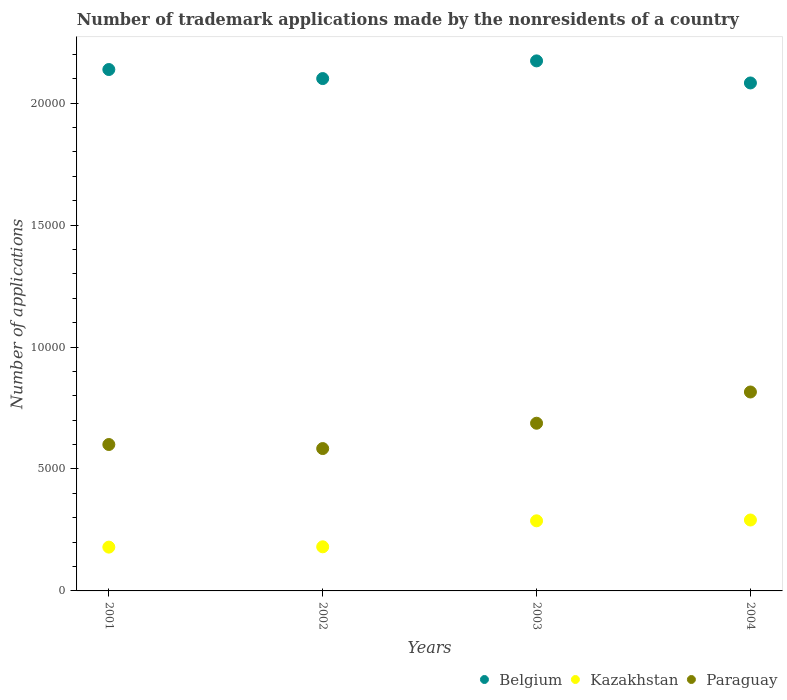How many different coloured dotlines are there?
Your response must be concise. 3. What is the number of trademark applications made by the nonresidents in Kazakhstan in 2002?
Your answer should be compact. 1809. Across all years, what is the maximum number of trademark applications made by the nonresidents in Kazakhstan?
Provide a succinct answer. 2908. Across all years, what is the minimum number of trademark applications made by the nonresidents in Belgium?
Provide a succinct answer. 2.08e+04. In which year was the number of trademark applications made by the nonresidents in Paraguay maximum?
Offer a very short reply. 2004. What is the total number of trademark applications made by the nonresidents in Belgium in the graph?
Ensure brevity in your answer.  8.50e+04. What is the difference between the number of trademark applications made by the nonresidents in Belgium in 2002 and that in 2004?
Keep it short and to the point. 180. What is the difference between the number of trademark applications made by the nonresidents in Belgium in 2003 and the number of trademark applications made by the nonresidents in Kazakhstan in 2001?
Your answer should be compact. 1.99e+04. What is the average number of trademark applications made by the nonresidents in Belgium per year?
Offer a terse response. 2.12e+04. In the year 2004, what is the difference between the number of trademark applications made by the nonresidents in Paraguay and number of trademark applications made by the nonresidents in Kazakhstan?
Your response must be concise. 5250. In how many years, is the number of trademark applications made by the nonresidents in Paraguay greater than 17000?
Make the answer very short. 0. What is the ratio of the number of trademark applications made by the nonresidents in Kazakhstan in 2001 to that in 2004?
Your answer should be very brief. 0.62. Is the number of trademark applications made by the nonresidents in Belgium in 2003 less than that in 2004?
Provide a short and direct response. No. What is the difference between the highest and the second highest number of trademark applications made by the nonresidents in Belgium?
Offer a very short reply. 354. What is the difference between the highest and the lowest number of trademark applications made by the nonresidents in Belgium?
Offer a very short reply. 905. In how many years, is the number of trademark applications made by the nonresidents in Kazakhstan greater than the average number of trademark applications made by the nonresidents in Kazakhstan taken over all years?
Provide a short and direct response. 2. How many dotlines are there?
Your answer should be compact. 3. What is the title of the graph?
Offer a very short reply. Number of trademark applications made by the nonresidents of a country. Does "Lao PDR" appear as one of the legend labels in the graph?
Your answer should be very brief. No. What is the label or title of the X-axis?
Keep it short and to the point. Years. What is the label or title of the Y-axis?
Ensure brevity in your answer.  Number of applications. What is the Number of applications in Belgium in 2001?
Provide a succinct answer. 2.14e+04. What is the Number of applications of Kazakhstan in 2001?
Make the answer very short. 1796. What is the Number of applications in Paraguay in 2001?
Your answer should be very brief. 6004. What is the Number of applications in Belgium in 2002?
Keep it short and to the point. 2.10e+04. What is the Number of applications in Kazakhstan in 2002?
Your answer should be very brief. 1809. What is the Number of applications of Paraguay in 2002?
Your response must be concise. 5838. What is the Number of applications of Belgium in 2003?
Ensure brevity in your answer.  2.17e+04. What is the Number of applications of Kazakhstan in 2003?
Ensure brevity in your answer.  2875. What is the Number of applications in Paraguay in 2003?
Your response must be concise. 6877. What is the Number of applications of Belgium in 2004?
Provide a succinct answer. 2.08e+04. What is the Number of applications in Kazakhstan in 2004?
Your answer should be very brief. 2908. What is the Number of applications in Paraguay in 2004?
Keep it short and to the point. 8158. Across all years, what is the maximum Number of applications in Belgium?
Ensure brevity in your answer.  2.17e+04. Across all years, what is the maximum Number of applications of Kazakhstan?
Your answer should be compact. 2908. Across all years, what is the maximum Number of applications in Paraguay?
Give a very brief answer. 8158. Across all years, what is the minimum Number of applications of Belgium?
Give a very brief answer. 2.08e+04. Across all years, what is the minimum Number of applications of Kazakhstan?
Provide a succinct answer. 1796. Across all years, what is the minimum Number of applications of Paraguay?
Your answer should be compact. 5838. What is the total Number of applications of Belgium in the graph?
Keep it short and to the point. 8.50e+04. What is the total Number of applications of Kazakhstan in the graph?
Your response must be concise. 9388. What is the total Number of applications in Paraguay in the graph?
Ensure brevity in your answer.  2.69e+04. What is the difference between the Number of applications in Belgium in 2001 and that in 2002?
Offer a terse response. 371. What is the difference between the Number of applications of Paraguay in 2001 and that in 2002?
Offer a terse response. 166. What is the difference between the Number of applications in Belgium in 2001 and that in 2003?
Your answer should be very brief. -354. What is the difference between the Number of applications in Kazakhstan in 2001 and that in 2003?
Keep it short and to the point. -1079. What is the difference between the Number of applications of Paraguay in 2001 and that in 2003?
Keep it short and to the point. -873. What is the difference between the Number of applications of Belgium in 2001 and that in 2004?
Your answer should be very brief. 551. What is the difference between the Number of applications of Kazakhstan in 2001 and that in 2004?
Give a very brief answer. -1112. What is the difference between the Number of applications of Paraguay in 2001 and that in 2004?
Provide a succinct answer. -2154. What is the difference between the Number of applications of Belgium in 2002 and that in 2003?
Ensure brevity in your answer.  -725. What is the difference between the Number of applications in Kazakhstan in 2002 and that in 2003?
Your answer should be compact. -1066. What is the difference between the Number of applications in Paraguay in 2002 and that in 2003?
Your response must be concise. -1039. What is the difference between the Number of applications in Belgium in 2002 and that in 2004?
Ensure brevity in your answer.  180. What is the difference between the Number of applications of Kazakhstan in 2002 and that in 2004?
Offer a very short reply. -1099. What is the difference between the Number of applications in Paraguay in 2002 and that in 2004?
Your response must be concise. -2320. What is the difference between the Number of applications in Belgium in 2003 and that in 2004?
Ensure brevity in your answer.  905. What is the difference between the Number of applications in Kazakhstan in 2003 and that in 2004?
Give a very brief answer. -33. What is the difference between the Number of applications of Paraguay in 2003 and that in 2004?
Make the answer very short. -1281. What is the difference between the Number of applications of Belgium in 2001 and the Number of applications of Kazakhstan in 2002?
Provide a succinct answer. 1.96e+04. What is the difference between the Number of applications in Belgium in 2001 and the Number of applications in Paraguay in 2002?
Give a very brief answer. 1.55e+04. What is the difference between the Number of applications of Kazakhstan in 2001 and the Number of applications of Paraguay in 2002?
Make the answer very short. -4042. What is the difference between the Number of applications of Belgium in 2001 and the Number of applications of Kazakhstan in 2003?
Your answer should be very brief. 1.85e+04. What is the difference between the Number of applications of Belgium in 2001 and the Number of applications of Paraguay in 2003?
Keep it short and to the point. 1.45e+04. What is the difference between the Number of applications of Kazakhstan in 2001 and the Number of applications of Paraguay in 2003?
Your answer should be very brief. -5081. What is the difference between the Number of applications of Belgium in 2001 and the Number of applications of Kazakhstan in 2004?
Your answer should be compact. 1.85e+04. What is the difference between the Number of applications in Belgium in 2001 and the Number of applications in Paraguay in 2004?
Provide a short and direct response. 1.32e+04. What is the difference between the Number of applications of Kazakhstan in 2001 and the Number of applications of Paraguay in 2004?
Provide a succinct answer. -6362. What is the difference between the Number of applications in Belgium in 2002 and the Number of applications in Kazakhstan in 2003?
Your answer should be very brief. 1.81e+04. What is the difference between the Number of applications of Belgium in 2002 and the Number of applications of Paraguay in 2003?
Offer a very short reply. 1.41e+04. What is the difference between the Number of applications in Kazakhstan in 2002 and the Number of applications in Paraguay in 2003?
Give a very brief answer. -5068. What is the difference between the Number of applications of Belgium in 2002 and the Number of applications of Kazakhstan in 2004?
Your answer should be very brief. 1.81e+04. What is the difference between the Number of applications in Belgium in 2002 and the Number of applications in Paraguay in 2004?
Offer a very short reply. 1.29e+04. What is the difference between the Number of applications in Kazakhstan in 2002 and the Number of applications in Paraguay in 2004?
Provide a short and direct response. -6349. What is the difference between the Number of applications in Belgium in 2003 and the Number of applications in Kazakhstan in 2004?
Provide a short and direct response. 1.88e+04. What is the difference between the Number of applications of Belgium in 2003 and the Number of applications of Paraguay in 2004?
Offer a terse response. 1.36e+04. What is the difference between the Number of applications of Kazakhstan in 2003 and the Number of applications of Paraguay in 2004?
Ensure brevity in your answer.  -5283. What is the average Number of applications in Belgium per year?
Offer a very short reply. 2.12e+04. What is the average Number of applications in Kazakhstan per year?
Give a very brief answer. 2347. What is the average Number of applications in Paraguay per year?
Ensure brevity in your answer.  6719.25. In the year 2001, what is the difference between the Number of applications in Belgium and Number of applications in Kazakhstan?
Your response must be concise. 1.96e+04. In the year 2001, what is the difference between the Number of applications of Belgium and Number of applications of Paraguay?
Provide a short and direct response. 1.54e+04. In the year 2001, what is the difference between the Number of applications of Kazakhstan and Number of applications of Paraguay?
Your answer should be compact. -4208. In the year 2002, what is the difference between the Number of applications of Belgium and Number of applications of Kazakhstan?
Your response must be concise. 1.92e+04. In the year 2002, what is the difference between the Number of applications in Belgium and Number of applications in Paraguay?
Offer a terse response. 1.52e+04. In the year 2002, what is the difference between the Number of applications of Kazakhstan and Number of applications of Paraguay?
Give a very brief answer. -4029. In the year 2003, what is the difference between the Number of applications of Belgium and Number of applications of Kazakhstan?
Your answer should be compact. 1.89e+04. In the year 2003, what is the difference between the Number of applications of Belgium and Number of applications of Paraguay?
Your answer should be very brief. 1.49e+04. In the year 2003, what is the difference between the Number of applications in Kazakhstan and Number of applications in Paraguay?
Your answer should be compact. -4002. In the year 2004, what is the difference between the Number of applications in Belgium and Number of applications in Kazakhstan?
Make the answer very short. 1.79e+04. In the year 2004, what is the difference between the Number of applications in Belgium and Number of applications in Paraguay?
Make the answer very short. 1.27e+04. In the year 2004, what is the difference between the Number of applications of Kazakhstan and Number of applications of Paraguay?
Provide a short and direct response. -5250. What is the ratio of the Number of applications in Belgium in 2001 to that in 2002?
Your response must be concise. 1.02. What is the ratio of the Number of applications in Paraguay in 2001 to that in 2002?
Make the answer very short. 1.03. What is the ratio of the Number of applications in Belgium in 2001 to that in 2003?
Keep it short and to the point. 0.98. What is the ratio of the Number of applications in Kazakhstan in 2001 to that in 2003?
Keep it short and to the point. 0.62. What is the ratio of the Number of applications in Paraguay in 2001 to that in 2003?
Ensure brevity in your answer.  0.87. What is the ratio of the Number of applications of Belgium in 2001 to that in 2004?
Your response must be concise. 1.03. What is the ratio of the Number of applications of Kazakhstan in 2001 to that in 2004?
Provide a succinct answer. 0.62. What is the ratio of the Number of applications of Paraguay in 2001 to that in 2004?
Keep it short and to the point. 0.74. What is the ratio of the Number of applications of Belgium in 2002 to that in 2003?
Your answer should be very brief. 0.97. What is the ratio of the Number of applications of Kazakhstan in 2002 to that in 2003?
Your answer should be compact. 0.63. What is the ratio of the Number of applications in Paraguay in 2002 to that in 2003?
Provide a succinct answer. 0.85. What is the ratio of the Number of applications in Belgium in 2002 to that in 2004?
Your response must be concise. 1.01. What is the ratio of the Number of applications of Kazakhstan in 2002 to that in 2004?
Offer a terse response. 0.62. What is the ratio of the Number of applications in Paraguay in 2002 to that in 2004?
Ensure brevity in your answer.  0.72. What is the ratio of the Number of applications in Belgium in 2003 to that in 2004?
Ensure brevity in your answer.  1.04. What is the ratio of the Number of applications of Kazakhstan in 2003 to that in 2004?
Make the answer very short. 0.99. What is the ratio of the Number of applications of Paraguay in 2003 to that in 2004?
Your answer should be compact. 0.84. What is the difference between the highest and the second highest Number of applications of Belgium?
Offer a terse response. 354. What is the difference between the highest and the second highest Number of applications of Kazakhstan?
Give a very brief answer. 33. What is the difference between the highest and the second highest Number of applications of Paraguay?
Offer a terse response. 1281. What is the difference between the highest and the lowest Number of applications in Belgium?
Keep it short and to the point. 905. What is the difference between the highest and the lowest Number of applications in Kazakhstan?
Offer a very short reply. 1112. What is the difference between the highest and the lowest Number of applications in Paraguay?
Provide a succinct answer. 2320. 